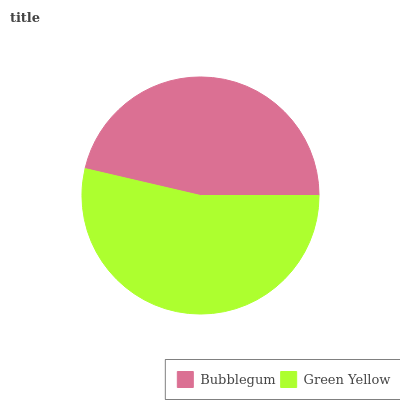Is Bubblegum the minimum?
Answer yes or no. Yes. Is Green Yellow the maximum?
Answer yes or no. Yes. Is Green Yellow the minimum?
Answer yes or no. No. Is Green Yellow greater than Bubblegum?
Answer yes or no. Yes. Is Bubblegum less than Green Yellow?
Answer yes or no. Yes. Is Bubblegum greater than Green Yellow?
Answer yes or no. No. Is Green Yellow less than Bubblegum?
Answer yes or no. No. Is Green Yellow the high median?
Answer yes or no. Yes. Is Bubblegum the low median?
Answer yes or no. Yes. Is Bubblegum the high median?
Answer yes or no. No. Is Green Yellow the low median?
Answer yes or no. No. 